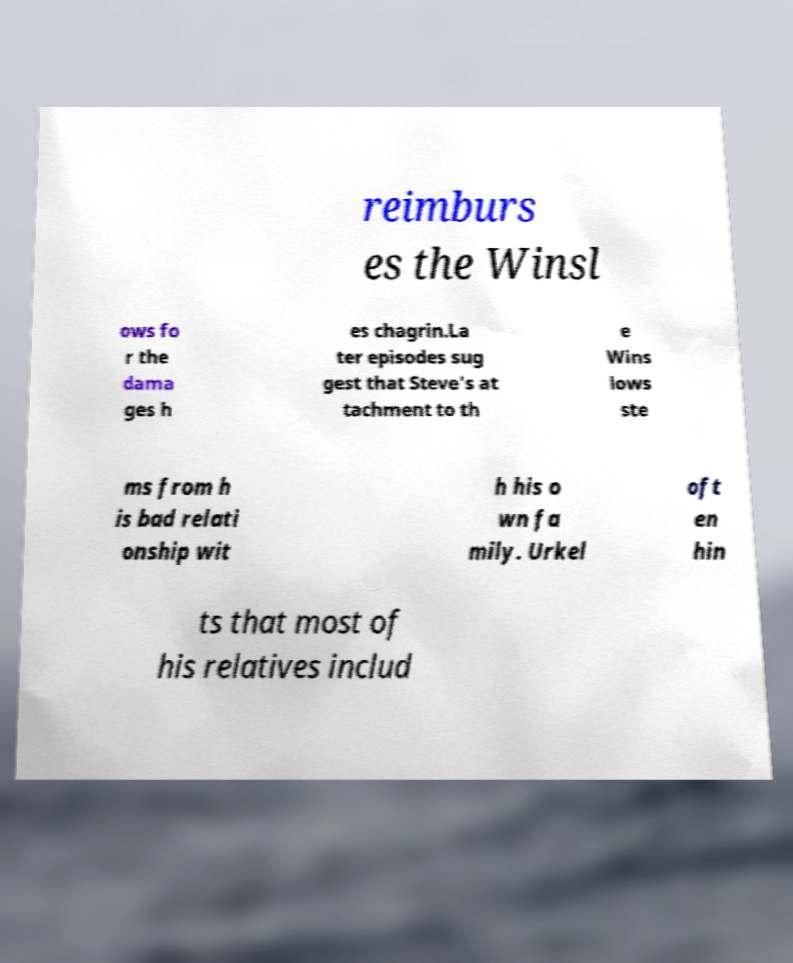Can you read and provide the text displayed in the image?This photo seems to have some interesting text. Can you extract and type it out for me? reimburs es the Winsl ows fo r the dama ges h es chagrin.La ter episodes sug gest that Steve's at tachment to th e Wins lows ste ms from h is bad relati onship wit h his o wn fa mily. Urkel oft en hin ts that most of his relatives includ 